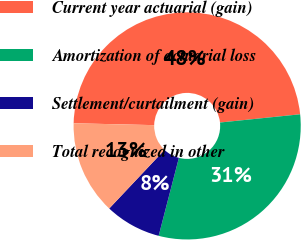Convert chart to OTSL. <chart><loc_0><loc_0><loc_500><loc_500><pie_chart><fcel>Current year actuarial (gain)<fcel>Amortization of actuarial loss<fcel>Settlement/curtailment (gain)<fcel>Total recognized in other<nl><fcel>48.0%<fcel>30.67%<fcel>8.0%<fcel>13.33%<nl></chart> 